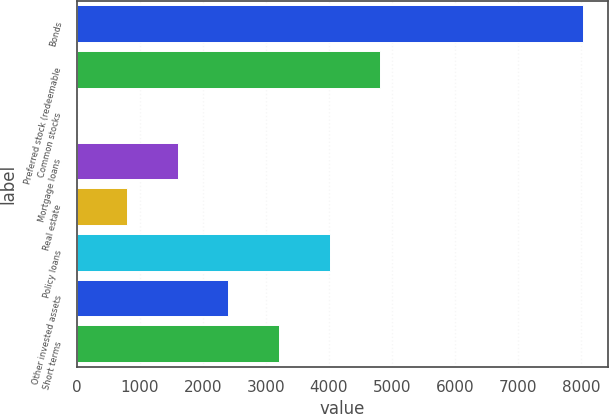Convert chart to OTSL. <chart><loc_0><loc_0><loc_500><loc_500><bar_chart><fcel>Bonds<fcel>Preferred stock (redeemable<fcel>Common stocks<fcel>Mortgage loans<fcel>Real estate<fcel>Policy loans<fcel>Other invested assets<fcel>Short terms<nl><fcel>8021<fcel>4813<fcel>1<fcel>1605<fcel>803<fcel>4011<fcel>2407<fcel>3209<nl></chart> 